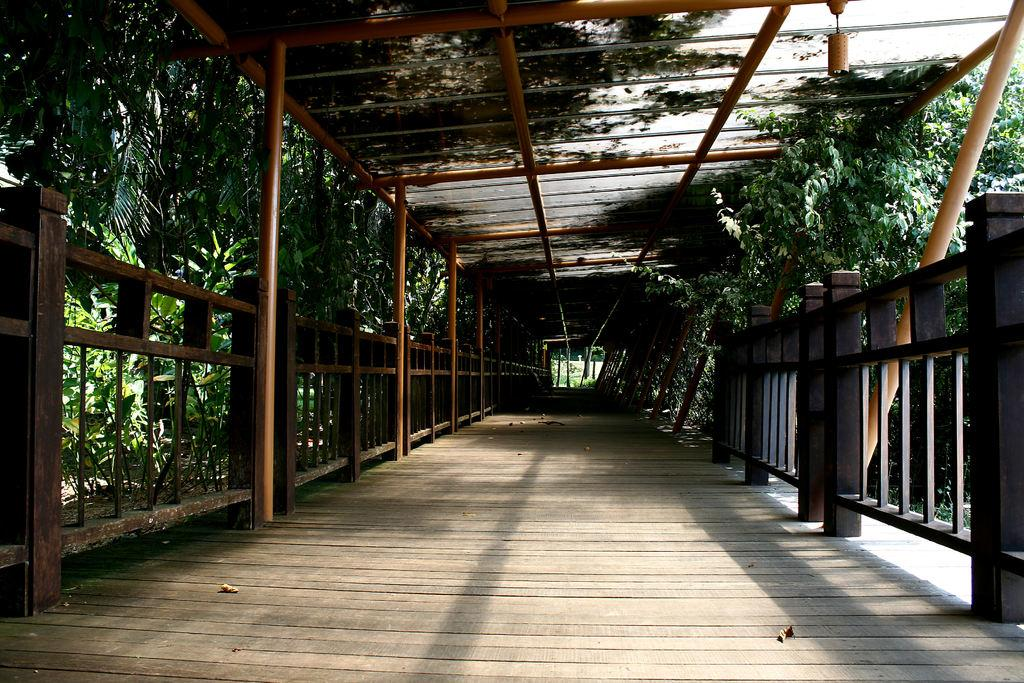What type of structure can be seen in the image? There is a fencing in the image. What are the vertical supports for the fencing? There are poles in the image. What type of natural elements are present in the image? There are trees in the image. What type of surface is at the bottom of the image? There is a wooden floor at the bottom of the image. What type of structure is at the top of the image? There is a roof with rods at the top of the image. What is the tendency of the bat to fly in the image? There is no bat present in the image, so it is not possible to determine its tendency to fly. 